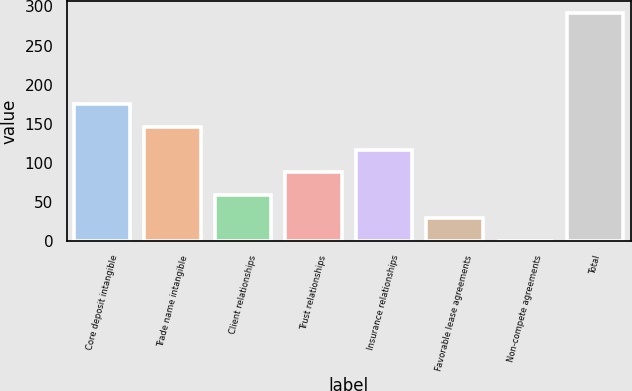<chart> <loc_0><loc_0><loc_500><loc_500><bar_chart><fcel>Core deposit intangible<fcel>Trade name intangible<fcel>Client relationships<fcel>Trust relationships<fcel>Insurance relationships<fcel>Favorable lease agreements<fcel>Non-compete agreements<fcel>Total<nl><fcel>175.28<fcel>146.1<fcel>58.56<fcel>87.74<fcel>116.92<fcel>29.38<fcel>0.2<fcel>292<nl></chart> 